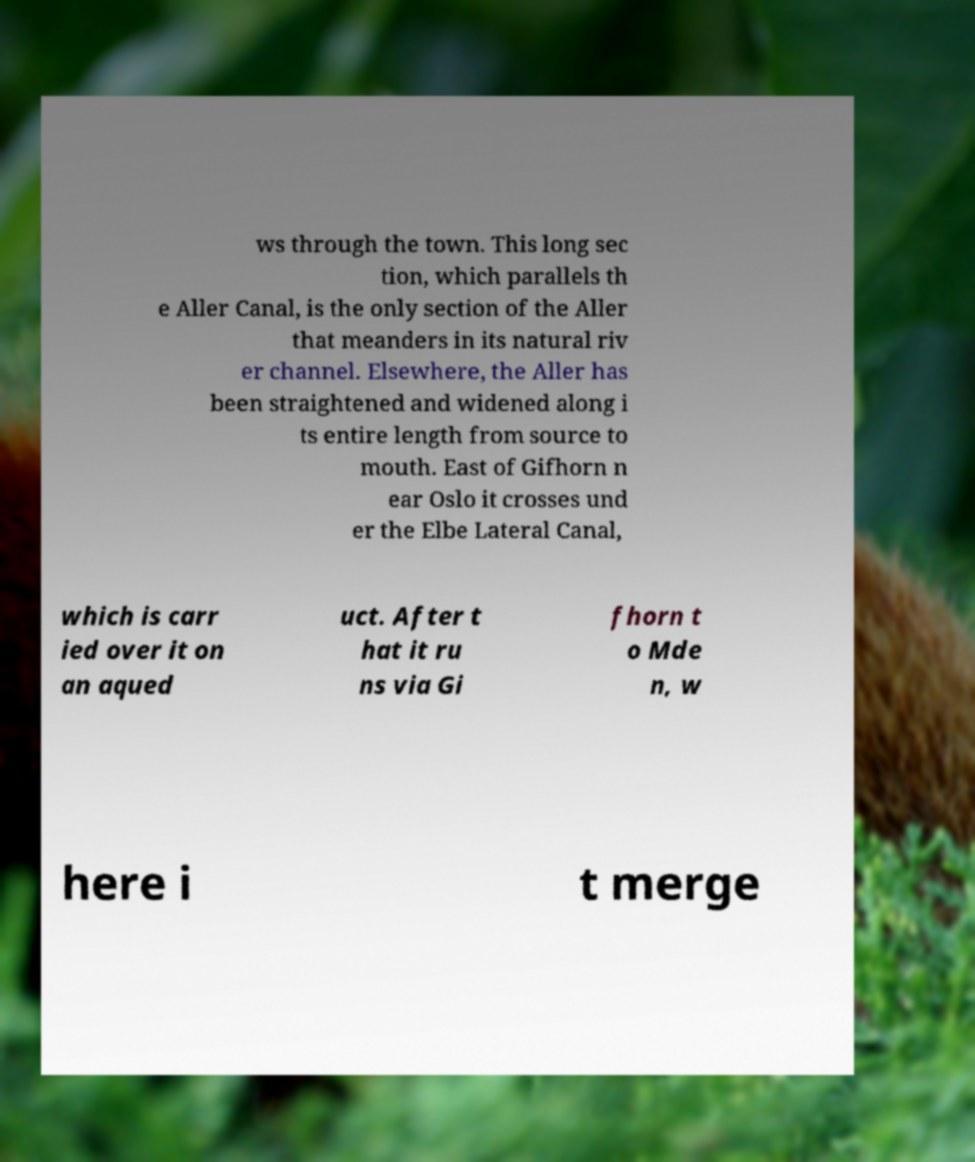There's text embedded in this image that I need extracted. Can you transcribe it verbatim? ws through the town. This long sec tion, which parallels th e Aller Canal, is the only section of the Aller that meanders in its natural riv er channel. Elsewhere, the Aller has been straightened and widened along i ts entire length from source to mouth. East of Gifhorn n ear Oslo it crosses und er the Elbe Lateral Canal, which is carr ied over it on an aqued uct. After t hat it ru ns via Gi fhorn t o Mde n, w here i t merge 